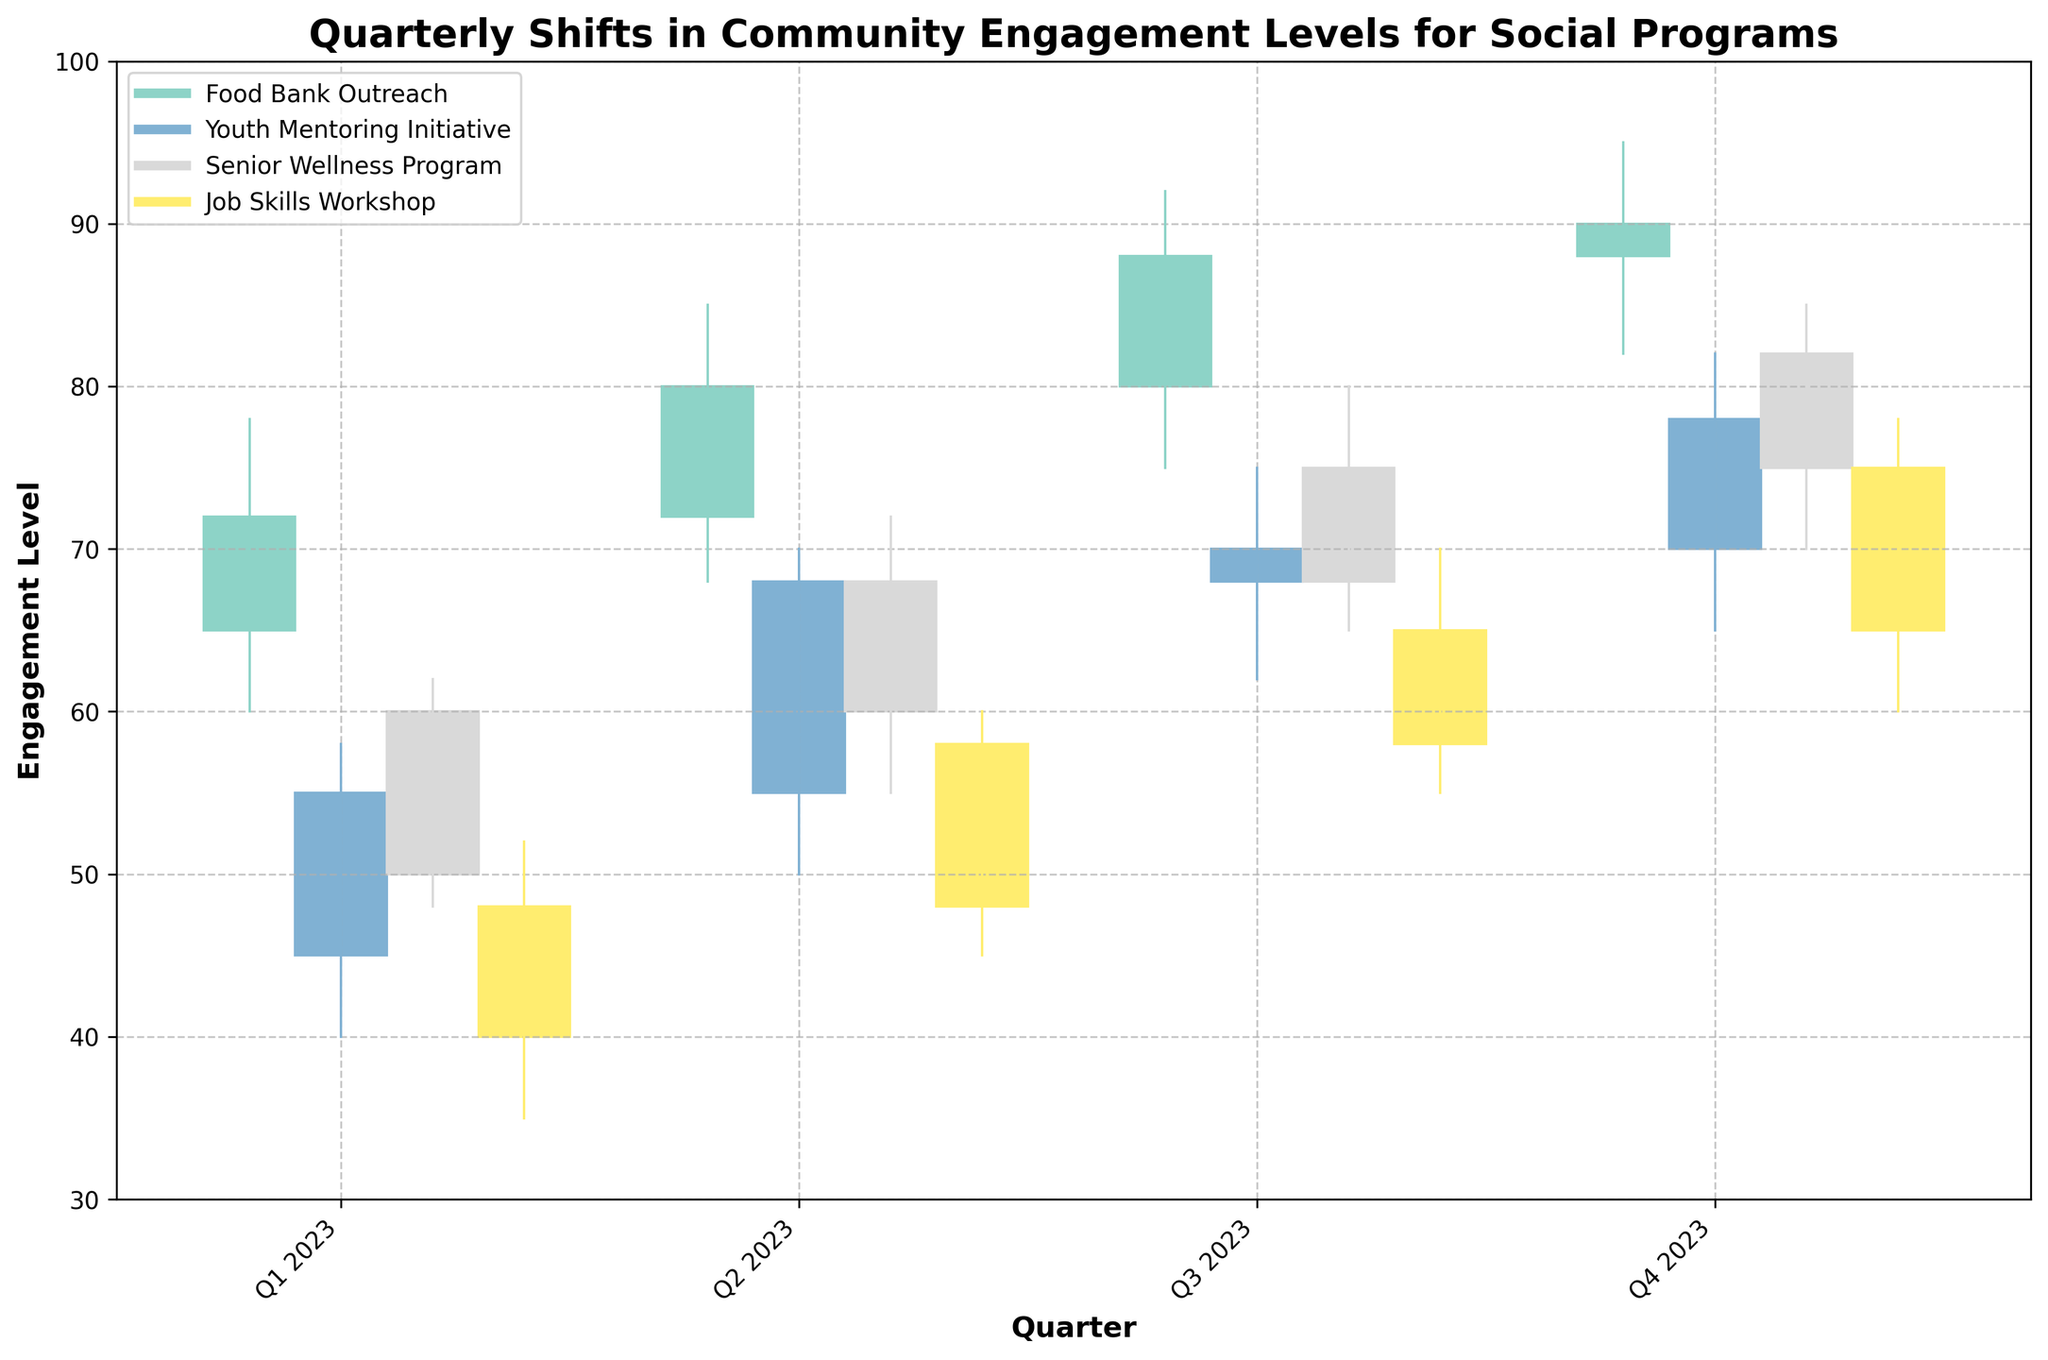What is the title of the figure? The title can be found at the top of the figure. It is given in a larger and bold font to distinguish it from other text elements.
Answer: Quarterly Shifts in Community Engagement Levels for Social Programs Which quarter had the highest engagement level for the Food Bank Outreach program? By observing the high points on the OHLC chart for the Food Bank Outreach program in each quarter, we see that Q4 2023 had the highest engagement level with a high of 95.
Answer: Q4 2023 What's the difference between the highest and lowest engagement levels for the Senior Wellness Program in Q3 2023? Refer to the OHLC data for the Senior Wellness Program in Q3 2023. The highest engagement level is 80, and the lowest is 65. The difference is 80 - 65 = 15.
Answer: 15 How did the engagement level for the Youth Mentoring Initiative change from Q1 2023 to Q4 2023? The open in Q1 2023 is 45, and the close in Q4 2023 is 78. The change is calculated as 78 - 45 = 33.
Answer: Increased by 33 Which program showed the least fluctuation in engagement level throughout the year 2023? To determine the least fluctuation, we compare the difference between high and low points for each program across all quarters. The Job Skills Workshop shows the least fluctuation; its highest fluctuation (in Q3 2023) is 70 - 55 = 15, which is lower than fluctuations in other programs.
Answer: Job Skills Workshop In which quarter did the Job Skills Workshop see the largest increase in engagement level? By comparing the opening and closing values for each quarter in the Job Skills Workshop data, the largest increase is seen from Q3 2023 (open 58, close 65), an increase of 7.
Answer: Q3 2023 Which program had the highest closing level in Q3 2023? Review the closing values for all programs in Q3 2023. The Food Bank Outreach program had the highest closing level with a value of 88.
Answer: Food Bank Outreach What is the average of the highest engagement levels recorded for the Youth Mentoring Initiative across all quarters? The high points for the Youth Mentoring Initiative across all quarters are: 58, 70, 75, 82. The average is calculated as (58 + 70 + 75 + 82) / 4 = 71.25.
Answer: 71.25 